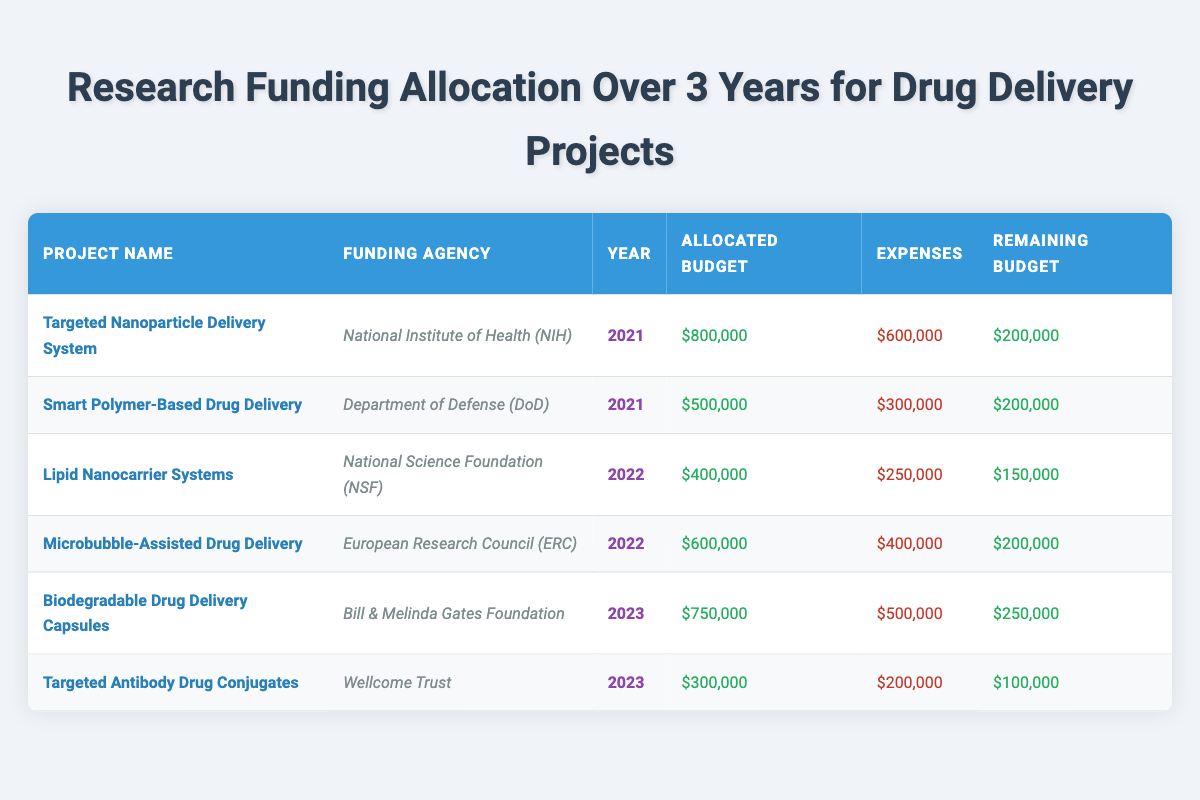What is the total allocated budget for the year 2023? The table shows the allocated budgets for each project in 2023: $750,000 for Biodegradable Drug Delivery Capsules and $300,000 for Targeted Antibody Drug Conjugates. Adding these values gives $750,000 + $300,000 = $1,050,000.
Answer: 1,050,000 Which project had the highest allocated budget in 2021? By reviewing the allocations for 2021, the table indicates $800,000 for Targeted Nanoparticle Delivery System and $500,000 for Smart Polymer-Based Drug Delivery. Thus, the highest allocation in 2021 is $800,000.
Answer: 800,000 Is the total expenses for the Lipid Nanocarrier Systems less than the expenses for Microbubble-Assisted Drug Delivery? The expenses for Lipid Nanocarrier Systems are $250,000 and for Microbubble-Assisted Drug Delivery are $400,000. Since $250,000 is less than $400,000, the statement is true.
Answer: Yes What is the remaining budget for the Targeted Antibody Drug Conjugates? The table states that the allocated budget is $300,000 and the expenses incurred are $200,000. Therefore, the remaining budget is calculated as $300,000 - $200,000 = $100,000.
Answer: 100,000 Which funding agency provided support for the project with the least remaining budget? The project with the least remaining budget is Targeted Antibody Drug Conjugates with a remaining budget of $100,000, funded by the Wellcome Trust. Thus, the answer is Wellcome Trust.
Answer: Wellcome Trust What is the average remaining budget across all projects in 2021 and 2022? Calculate the remaining budgets for both years: 2021 has remaining budgets of $200,000 (Targeted Nanoparticle Delivery) and $200,000 (Smart Polymer-Based Drug Delivery), totaling $400,000. For 2022, the remaining budgets are $150,000 (Lipid Nanocarrier Systems) and $200,000 (Microbubble-Assisted Drug Delivery), totaling $350,000. Combined, these amounts total $750,000. There are 4 projects, so the average remaining budget is $750,000 / 4 = $187,500.
Answer: 187,500 How much more was allocated to the Microbubble-Assisted Drug Delivery compared to the Lipid Nanocarrier Systems? The allocated budget for Microbubble-Assisted Drug Delivery is $600,000 and for Lipid Nanocarrier Systems is $400,000. To find the difference, subtract: $600,000 - $400,000 = $200,000.
Answer: 200,000 Did any project exceed its allocated budget in terms of expenses? Analyzing the expenses, all projects have expenses less than or equal to their allocated budgets. Specifically, Targeted Nanoparticle Delivery System ($600,000 expenses vs. $800,000 budget) and others have expenses lower than allocated budgets. Hence, the answer is no.
Answer: No Which funding agency allocated the second-highest budget in 2022? In 2022, the budgets were $400,000 (Lipid Nanocarrier Systems - NSF) and $600,000 (Microbubble-Assisted Drug Delivery - ERC). The second-highest is therefore $400,000, funded by the National Science Foundation.
Answer: National Science Foundation 